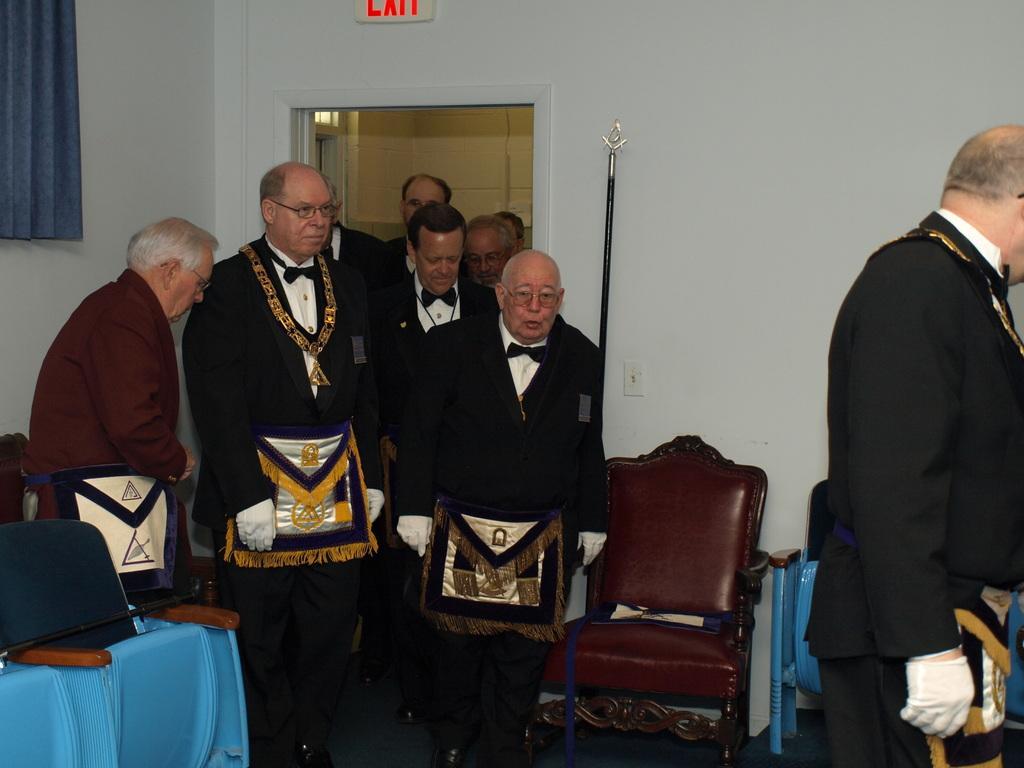How would you summarize this image in a sentence or two? There is a group of a people. All are standing position. All are wearing black shirts and one person is wearing brown coat. They are wearing gloves. On the background there is a curtain ,and chairs. 